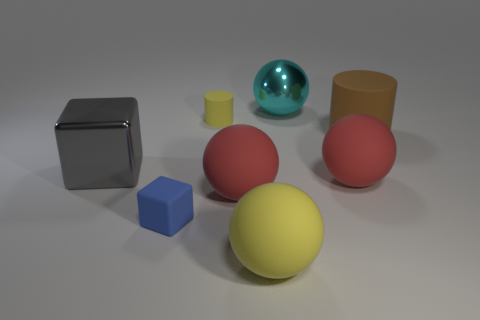Subtract all gray spheres. Subtract all brown cubes. How many spheres are left? 4 Add 1 yellow rubber cylinders. How many objects exist? 9 Subtract all blocks. How many objects are left? 6 Subtract 1 cyan spheres. How many objects are left? 7 Subtract all brown things. Subtract all gray shiny blocks. How many objects are left? 6 Add 4 big rubber cylinders. How many big rubber cylinders are left? 5 Add 6 brown rubber objects. How many brown rubber objects exist? 7 